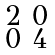<formula> <loc_0><loc_0><loc_500><loc_500>\begin{smallmatrix} 2 & 0 \\ 0 & 4 \end{smallmatrix}</formula> 